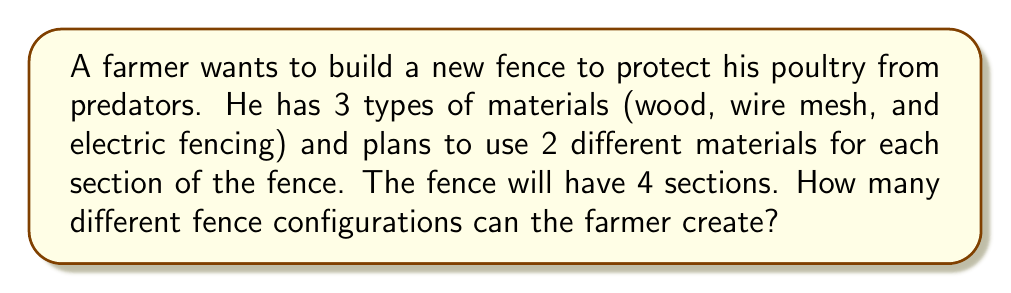Show me your answer to this math problem. Let's approach this step-by-step:

1) First, we need to determine how many ways we can choose 2 materials out of 3 for each section. This is a combination problem, denoted as $\binom{3}{2}$.

   $\binom{3}{2} = \frac{3!}{2!(3-2)!} = \frac{3 \cdot 2 \cdot 1}{(2 \cdot 1)(1)} = 3$

2) So, for each section, there are 3 possible combinations of materials.

3) The fence has 4 sections, and for each section, we make an independent choice of materials.

4) When we have a series of independent choices, we multiply the number of possibilities for each choice.

5) Therefore, the total number of different fence configurations is:

   $3 \cdot 3 \cdot 3 \cdot 3 = 3^4 = 81$

Thus, the farmer can create 81 different fence configurations.
Answer: 81 